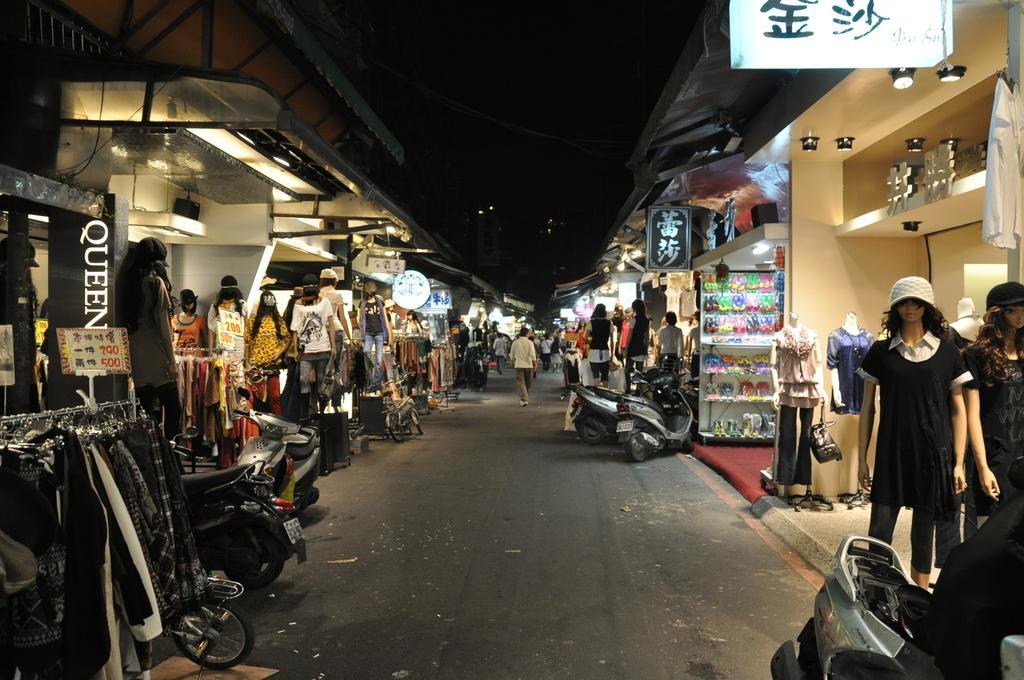How would you summarize this image in a sentence or two? In this picture i can see the man who is wearing shirt, trouser and shoe. He is the walking on the road. On the right and left side i can see many statues which are kept in front of the shops. In the bottom left corner i can see the clothes which are hanging on this steel stand. Beside that i can see many vehicles. On the right i can see the lights & boards. At the top i can see the darkness. In the bottom right there are statues who are wearing the clothes and kept near to the bike. 